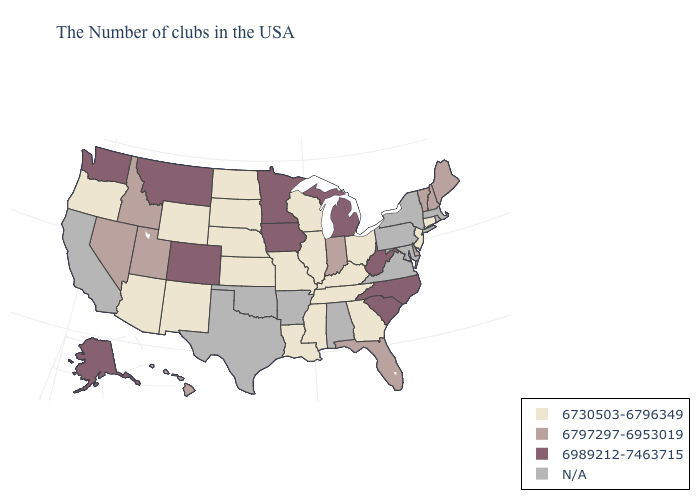Name the states that have a value in the range 6797297-6953019?
Concise answer only. Maine, New Hampshire, Vermont, Delaware, Florida, Indiana, Utah, Idaho, Nevada, Hawaii. How many symbols are there in the legend?
Short answer required. 4. Name the states that have a value in the range N/A?
Concise answer only. Massachusetts, Rhode Island, New York, Maryland, Pennsylvania, Virginia, Alabama, Arkansas, Oklahoma, Texas, California. Does Michigan have the lowest value in the USA?
Quick response, please. No. Does Florida have the lowest value in the USA?
Answer briefly. No. What is the highest value in states that border North Carolina?
Give a very brief answer. 6989212-7463715. Name the states that have a value in the range 6797297-6953019?
Concise answer only. Maine, New Hampshire, Vermont, Delaware, Florida, Indiana, Utah, Idaho, Nevada, Hawaii. What is the value of Kansas?
Be succinct. 6730503-6796349. What is the value of Colorado?
Quick response, please. 6989212-7463715. What is the lowest value in the USA?
Quick response, please. 6730503-6796349. What is the highest value in the USA?
Keep it brief. 6989212-7463715. Among the states that border New Mexico , does Arizona have the lowest value?
Write a very short answer. Yes. Name the states that have a value in the range 6989212-7463715?
Answer briefly. North Carolina, South Carolina, West Virginia, Michigan, Minnesota, Iowa, Colorado, Montana, Washington, Alaska. How many symbols are there in the legend?
Answer briefly. 4. What is the value of North Dakota?
Short answer required. 6730503-6796349. 